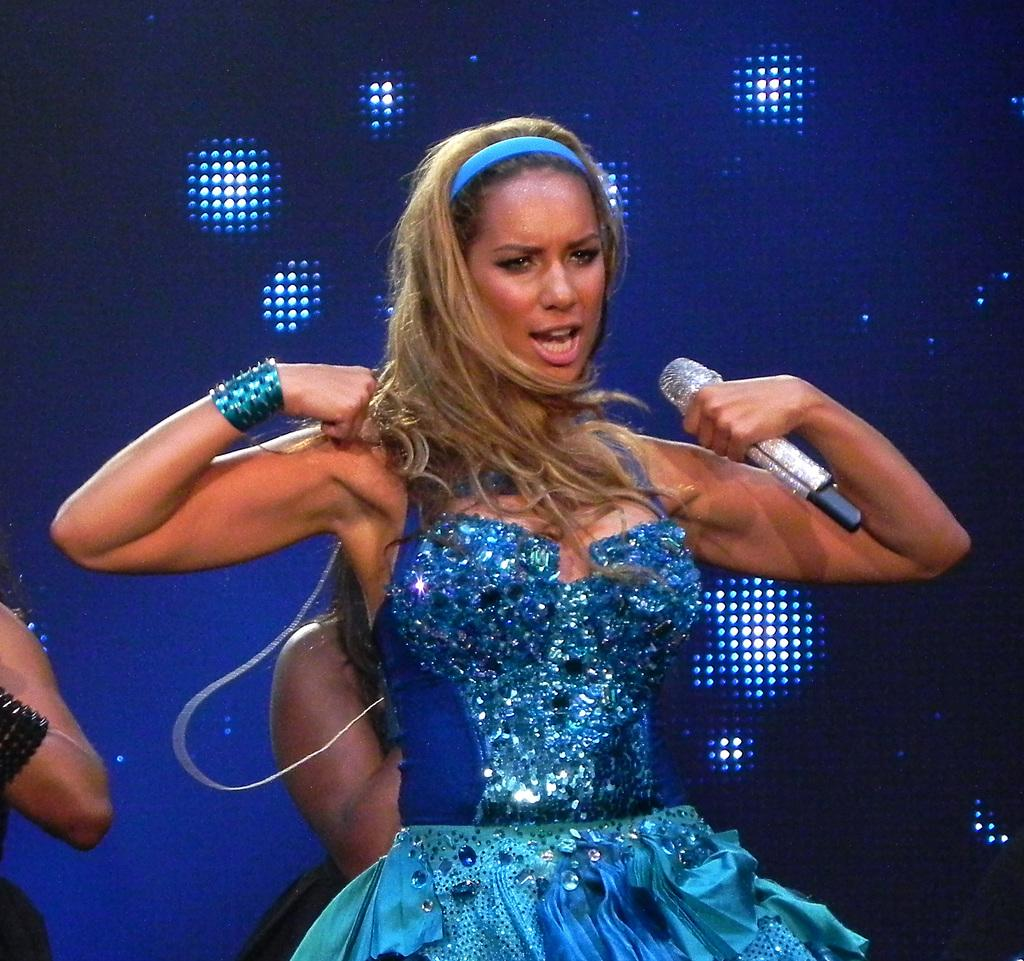Who is the main subject in the image? There is a lady in the center of the image. What is the lady holding in her hand? The lady is holding a mic in her hand. Can you describe the background of the image? There are other people in the background of the image, and there are lights visible on a screen. What type of crack can be seen on the lady's toothbrush in the image? There is no toothbrush present in the image, and therefore no crack can be observed. 